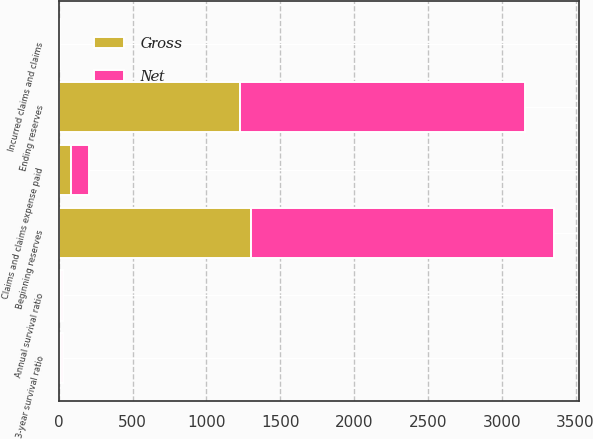<chart> <loc_0><loc_0><loc_500><loc_500><stacked_bar_chart><ecel><fcel>Beginning reserves<fcel>Incurred claims and claims<fcel>Claims and claims expense paid<fcel>Ending reserves<fcel>Annual survival ratio<fcel>3-year survival ratio<nl><fcel>Net<fcel>2053<fcel>4<fcel>124<fcel>1933<fcel>15.4<fcel>13.4<nl><fcel>Gross<fcel>1302<fcel>8<fcel>82<fcel>1228<fcel>15.1<fcel>14.4<nl></chart> 